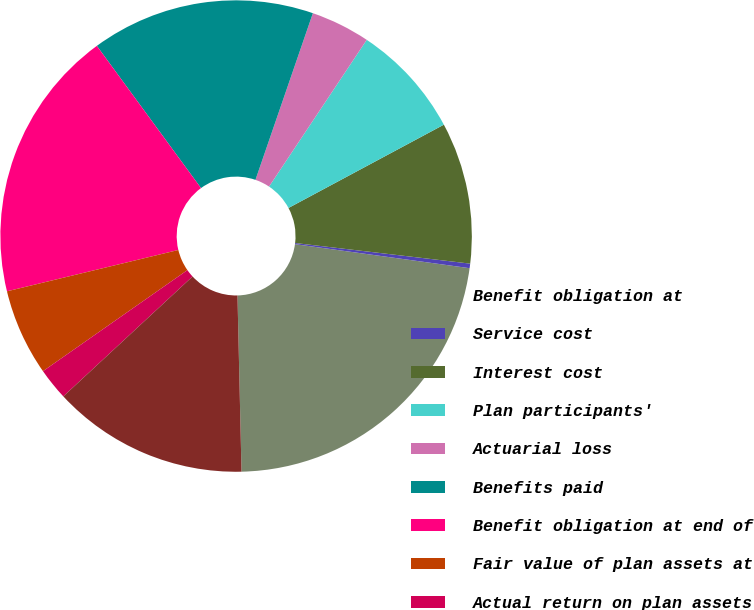Convert chart to OTSL. <chart><loc_0><loc_0><loc_500><loc_500><pie_chart><fcel>Benefit obligation at<fcel>Service cost<fcel>Interest cost<fcel>Plan participants'<fcel>Actuarial loss<fcel>Benefits paid<fcel>Benefit obligation at end of<fcel>Fair value of plan assets at<fcel>Actual return on plan assets<fcel>Employer contributions<nl><fcel>22.46%<fcel>0.31%<fcel>9.7%<fcel>7.82%<fcel>4.07%<fcel>15.34%<fcel>18.71%<fcel>5.95%<fcel>2.19%<fcel>13.46%<nl></chart> 